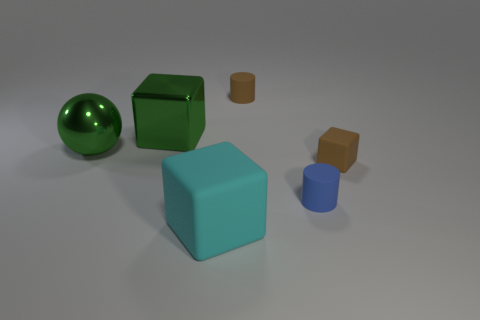There is a big shiny object that is the same color as the big shiny ball; what is its shape?
Ensure brevity in your answer.  Cube. There is a matte cube behind the large cyan rubber object; what size is it?
Your answer should be compact. Small. The matte object that is to the left of the tiny brown matte object behind the metallic block that is to the left of the small brown rubber cylinder is what color?
Offer a terse response. Cyan. The tiny cylinder right of the brown matte cylinder that is behind the blue thing is what color?
Your response must be concise. Blue. Are there more large rubber objects behind the metallic sphere than large rubber objects that are in front of the brown cylinder?
Provide a succinct answer. No. Do the big cube in front of the tiny blue object and the cylinder in front of the large metal cube have the same material?
Your response must be concise. Yes. Are there any tiny blue cylinders left of the cyan cube?
Keep it short and to the point. No. What number of blue things are either rubber objects or small rubber cylinders?
Your answer should be compact. 1. Is the material of the small brown cube the same as the big block that is on the left side of the big rubber object?
Provide a short and direct response. No. There is another shiny object that is the same shape as the large cyan object; what size is it?
Ensure brevity in your answer.  Large. 